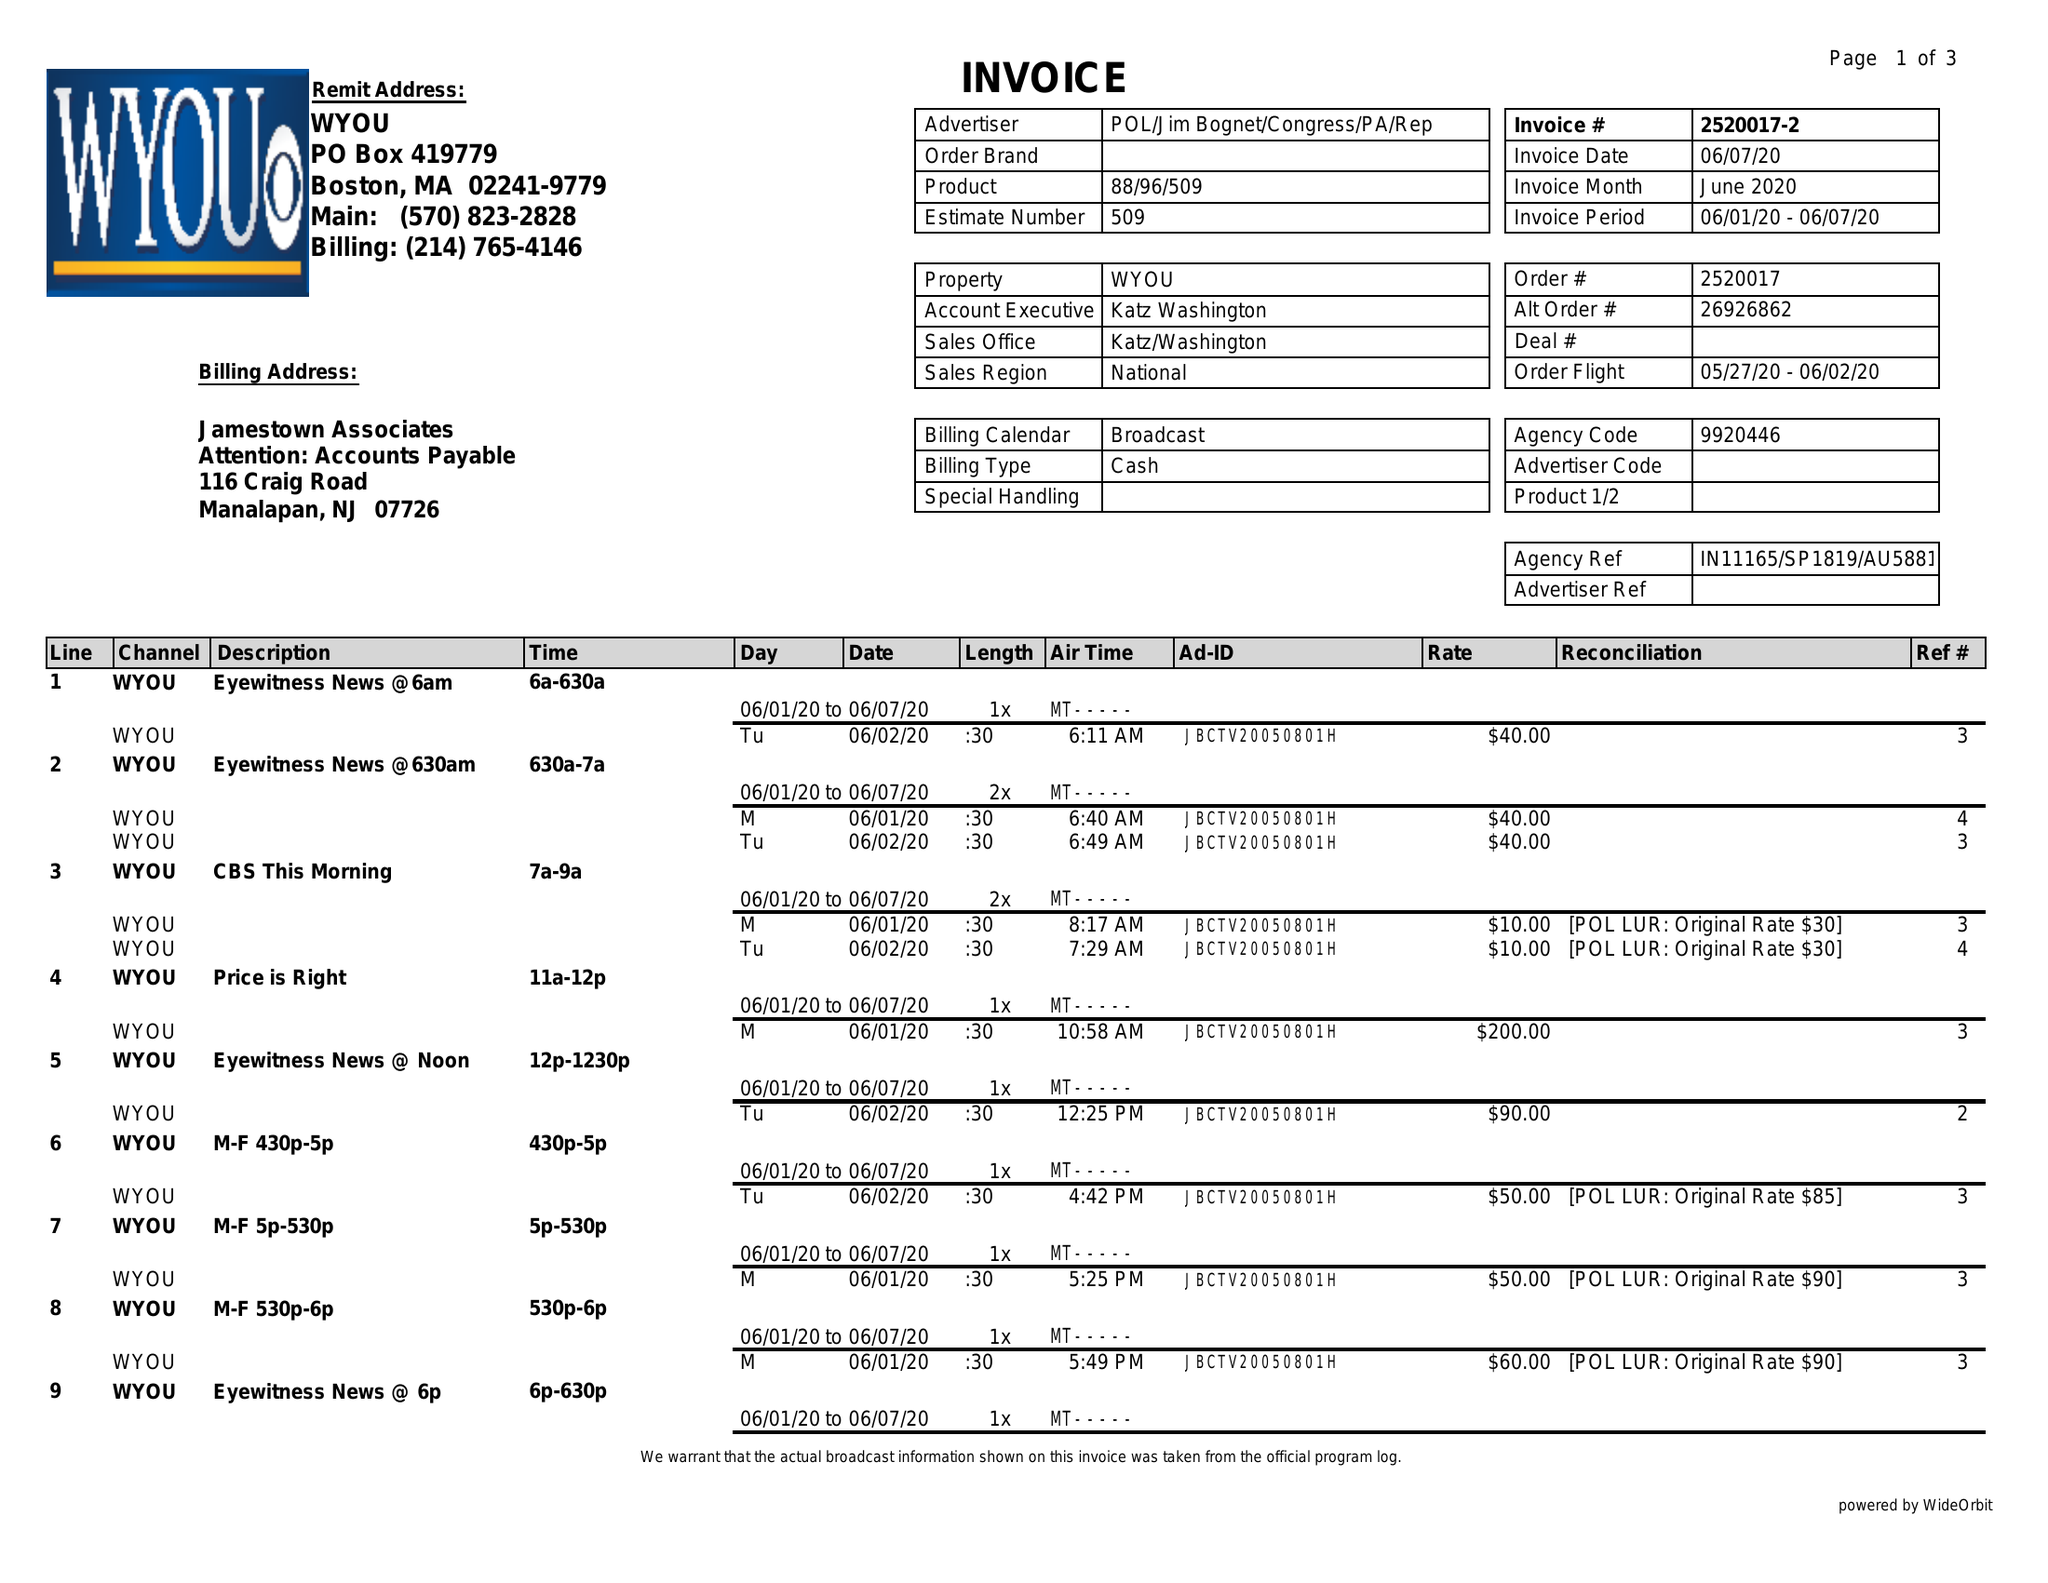What is the value for the gross_amount?
Answer the question using a single word or phrase. 1470.00 